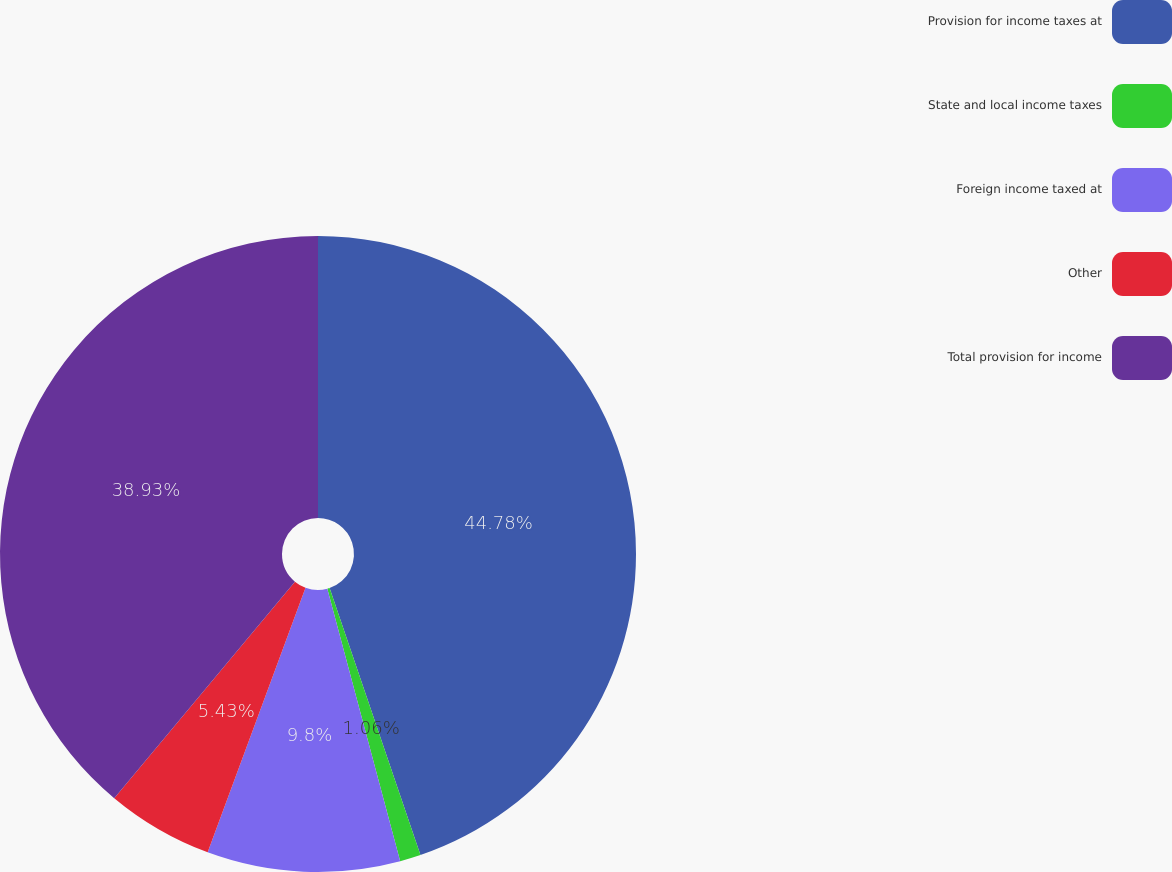Convert chart. <chart><loc_0><loc_0><loc_500><loc_500><pie_chart><fcel>Provision for income taxes at<fcel>State and local income taxes<fcel>Foreign income taxed at<fcel>Other<fcel>Total provision for income<nl><fcel>44.78%<fcel>1.06%<fcel>9.8%<fcel>5.43%<fcel>38.93%<nl></chart> 